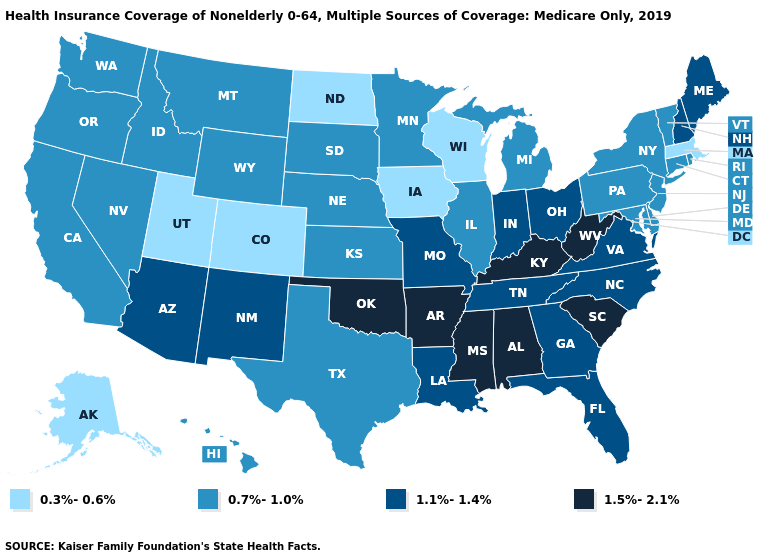Name the states that have a value in the range 1.1%-1.4%?
Concise answer only. Arizona, Florida, Georgia, Indiana, Louisiana, Maine, Missouri, New Hampshire, New Mexico, North Carolina, Ohio, Tennessee, Virginia. Among the states that border Kansas , does Nebraska have the highest value?
Give a very brief answer. No. What is the value of Florida?
Quick response, please. 1.1%-1.4%. Name the states that have a value in the range 0.7%-1.0%?
Concise answer only. California, Connecticut, Delaware, Hawaii, Idaho, Illinois, Kansas, Maryland, Michigan, Minnesota, Montana, Nebraska, Nevada, New Jersey, New York, Oregon, Pennsylvania, Rhode Island, South Dakota, Texas, Vermont, Washington, Wyoming. What is the value of Ohio?
Give a very brief answer. 1.1%-1.4%. What is the value of New Mexico?
Write a very short answer. 1.1%-1.4%. What is the value of Wyoming?
Concise answer only. 0.7%-1.0%. Does Mississippi have a higher value than Missouri?
Answer briefly. Yes. What is the lowest value in the USA?
Answer briefly. 0.3%-0.6%. Name the states that have a value in the range 0.7%-1.0%?
Be succinct. California, Connecticut, Delaware, Hawaii, Idaho, Illinois, Kansas, Maryland, Michigan, Minnesota, Montana, Nebraska, Nevada, New Jersey, New York, Oregon, Pennsylvania, Rhode Island, South Dakota, Texas, Vermont, Washington, Wyoming. Does Vermont have a higher value than Kentucky?
Quick response, please. No. Does North Dakota have the lowest value in the MidWest?
Answer briefly. Yes. Name the states that have a value in the range 1.1%-1.4%?
Be succinct. Arizona, Florida, Georgia, Indiana, Louisiana, Maine, Missouri, New Hampshire, New Mexico, North Carolina, Ohio, Tennessee, Virginia. What is the value of Ohio?
Keep it brief. 1.1%-1.4%. Which states have the highest value in the USA?
Quick response, please. Alabama, Arkansas, Kentucky, Mississippi, Oklahoma, South Carolina, West Virginia. 